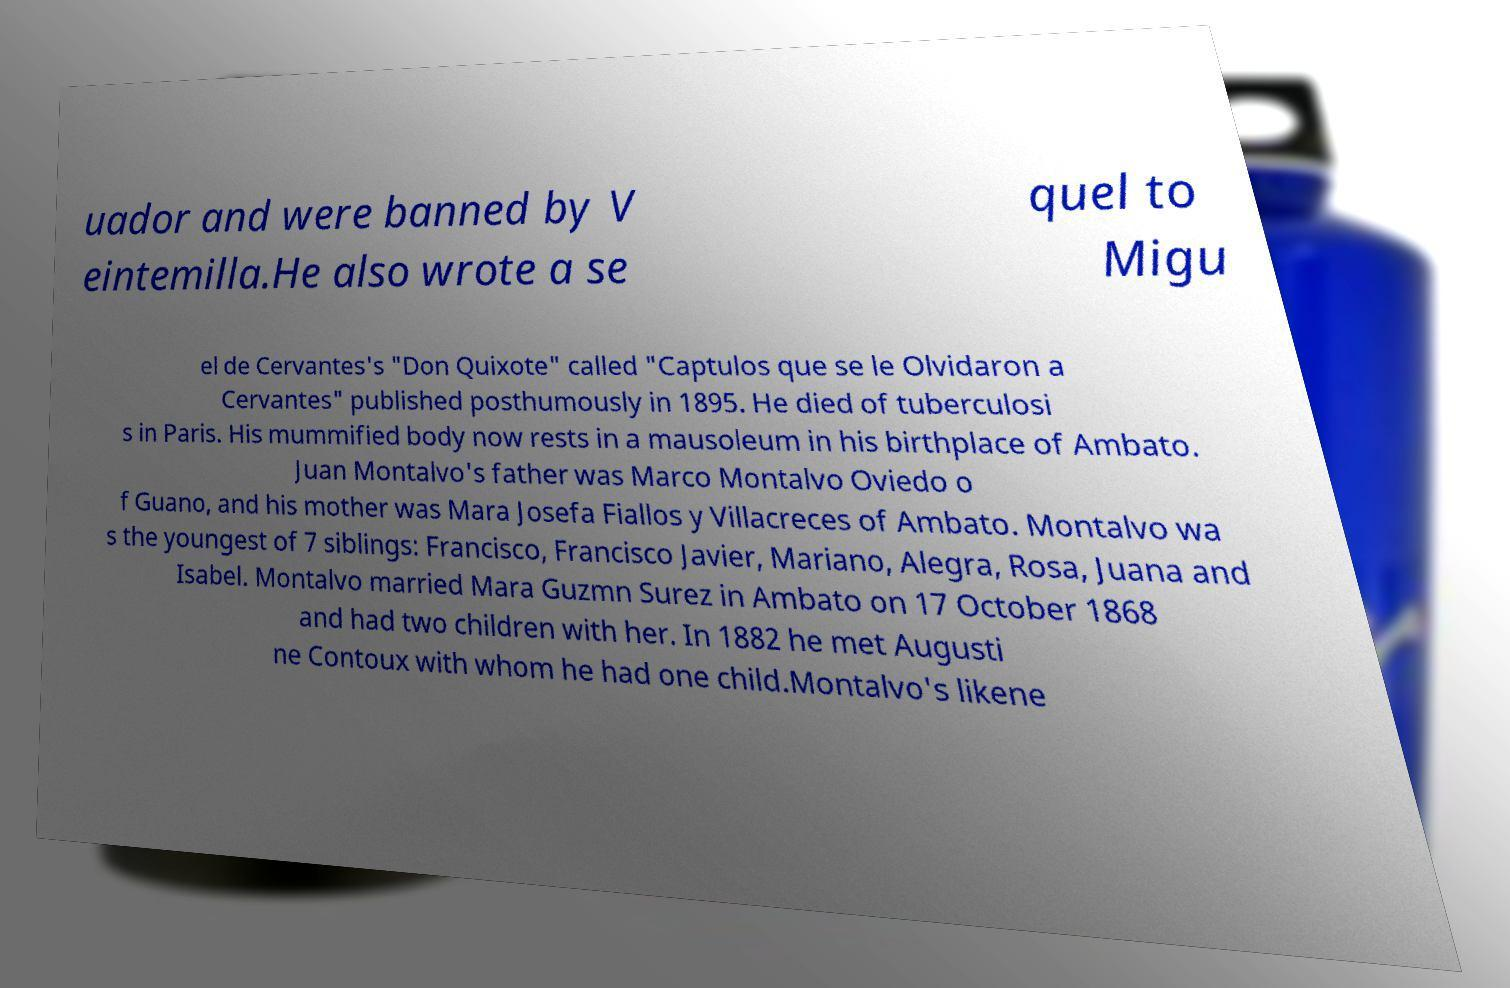Could you assist in decoding the text presented in this image and type it out clearly? uador and were banned by V eintemilla.He also wrote a se quel to Migu el de Cervantes's "Don Quixote" called "Captulos que se le Olvidaron a Cervantes" published posthumously in 1895. He died of tuberculosi s in Paris. His mummified body now rests in a mausoleum in his birthplace of Ambato. Juan Montalvo's father was Marco Montalvo Oviedo o f Guano, and his mother was Mara Josefa Fiallos y Villacreces of Ambato. Montalvo wa s the youngest of 7 siblings: Francisco, Francisco Javier, Mariano, Alegra, Rosa, Juana and Isabel. Montalvo married Mara Guzmn Surez in Ambato on 17 October 1868 and had two children with her. In 1882 he met Augusti ne Contoux with whom he had one child.Montalvo's likene 